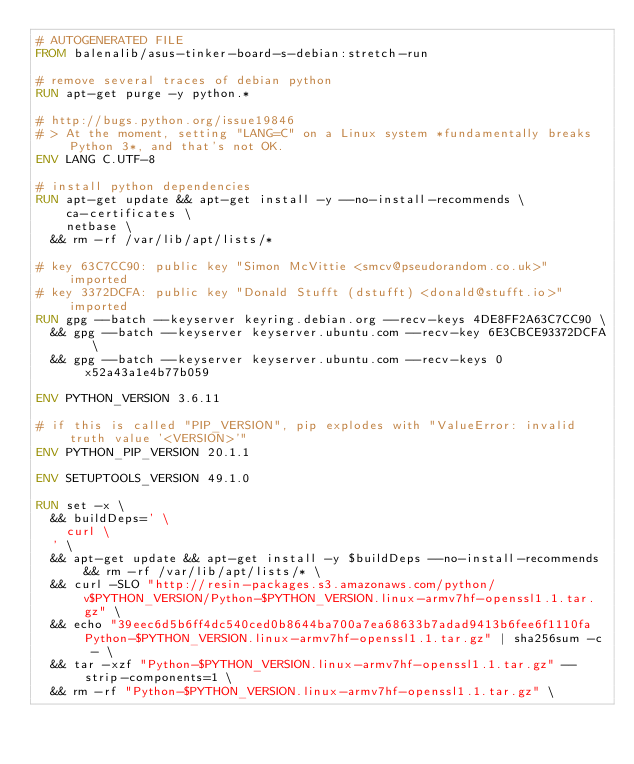<code> <loc_0><loc_0><loc_500><loc_500><_Dockerfile_># AUTOGENERATED FILE
FROM balenalib/asus-tinker-board-s-debian:stretch-run

# remove several traces of debian python
RUN apt-get purge -y python.*

# http://bugs.python.org/issue19846
# > At the moment, setting "LANG=C" on a Linux system *fundamentally breaks Python 3*, and that's not OK.
ENV LANG C.UTF-8

# install python dependencies
RUN apt-get update && apt-get install -y --no-install-recommends \
		ca-certificates \
		netbase \
	&& rm -rf /var/lib/apt/lists/*

# key 63C7CC90: public key "Simon McVittie <smcv@pseudorandom.co.uk>" imported
# key 3372DCFA: public key "Donald Stufft (dstufft) <donald@stufft.io>" imported
RUN gpg --batch --keyserver keyring.debian.org --recv-keys 4DE8FF2A63C7CC90 \
	&& gpg --batch --keyserver keyserver.ubuntu.com --recv-key 6E3CBCE93372DCFA \
	&& gpg --batch --keyserver keyserver.ubuntu.com --recv-keys 0x52a43a1e4b77b059

ENV PYTHON_VERSION 3.6.11

# if this is called "PIP_VERSION", pip explodes with "ValueError: invalid truth value '<VERSION>'"
ENV PYTHON_PIP_VERSION 20.1.1

ENV SETUPTOOLS_VERSION 49.1.0

RUN set -x \
	&& buildDeps=' \
		curl \
	' \
	&& apt-get update && apt-get install -y $buildDeps --no-install-recommends && rm -rf /var/lib/apt/lists/* \
	&& curl -SLO "http://resin-packages.s3.amazonaws.com/python/v$PYTHON_VERSION/Python-$PYTHON_VERSION.linux-armv7hf-openssl1.1.tar.gz" \
	&& echo "39eec6d5b6ff4dc540ced0b8644ba700a7ea68633b7adad9413b6fee6f1110fa  Python-$PYTHON_VERSION.linux-armv7hf-openssl1.1.tar.gz" | sha256sum -c - \
	&& tar -xzf "Python-$PYTHON_VERSION.linux-armv7hf-openssl1.1.tar.gz" --strip-components=1 \
	&& rm -rf "Python-$PYTHON_VERSION.linux-armv7hf-openssl1.1.tar.gz" \</code> 